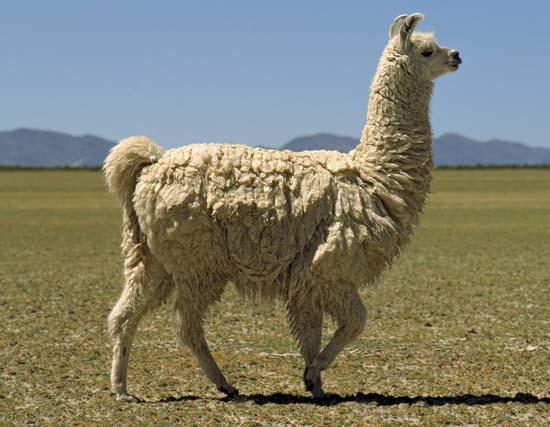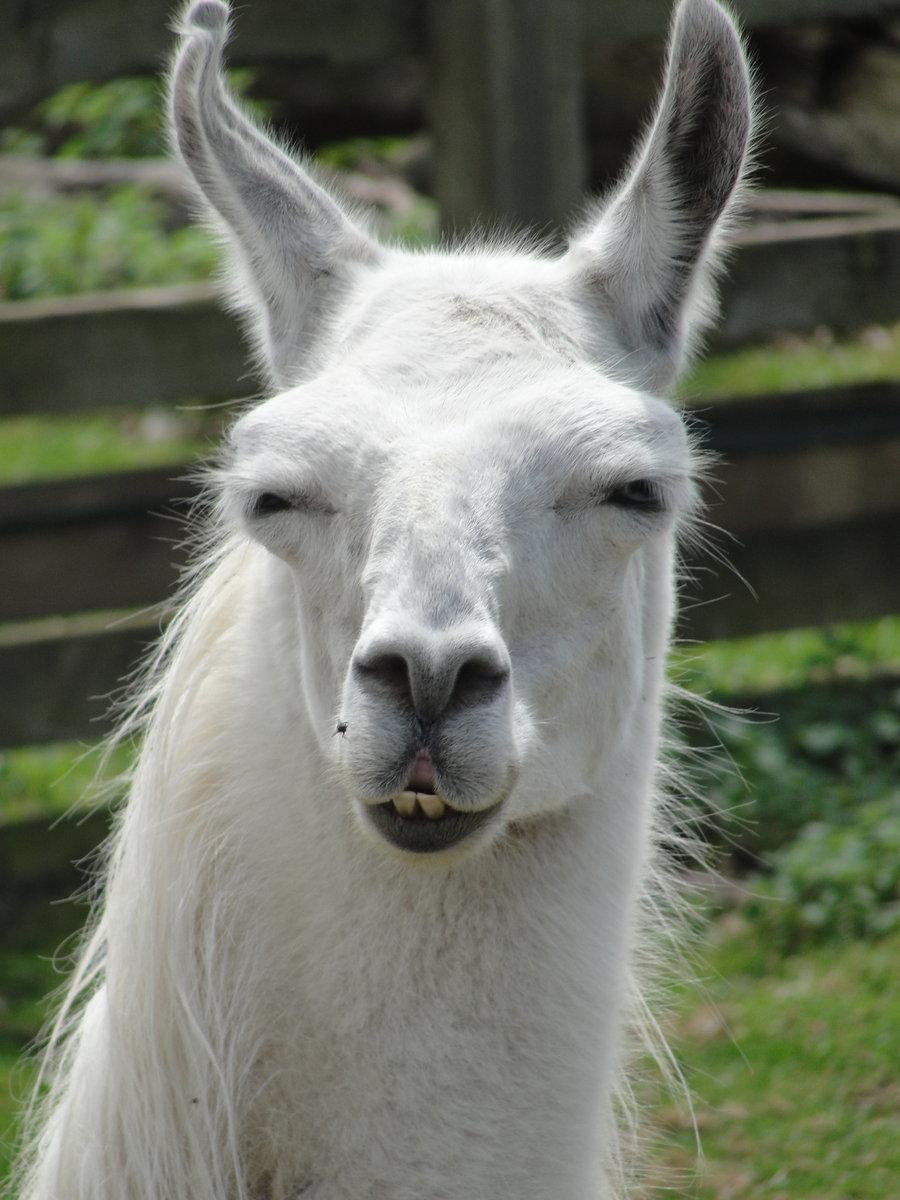The first image is the image on the left, the second image is the image on the right. Analyze the images presented: Is the assertion "An image features a white forward-facing llama showing its protruding lower teeth." valid? Answer yes or no. Yes. The first image is the image on the left, the second image is the image on the right. Analyze the images presented: Is the assertion "The left and right image contains the same number of llamas." valid? Answer yes or no. Yes. 